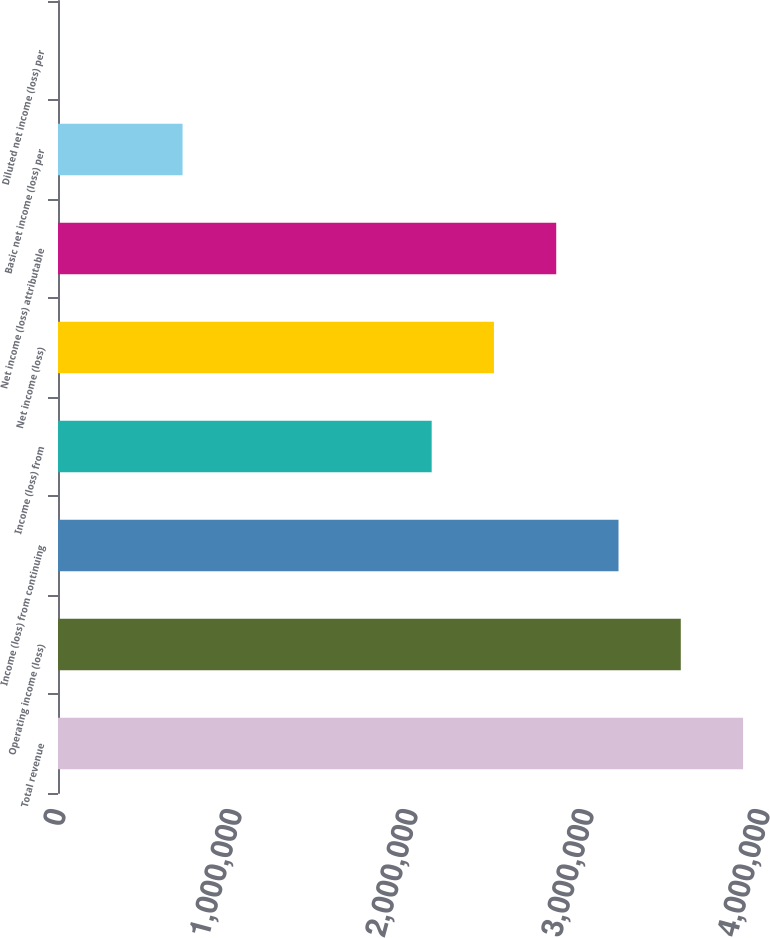<chart> <loc_0><loc_0><loc_500><loc_500><bar_chart><fcel>Total revenue<fcel>Operating income (loss)<fcel>Income (loss) from continuing<fcel>Income (loss) from<fcel>Net income (loss)<fcel>Net income (loss) attributable<fcel>Basic net income (loss) per<fcel>Diluted net income (loss) per<nl><fcel>3.89239e+06<fcel>3.53854e+06<fcel>3.18469e+06<fcel>2.12312e+06<fcel>2.47698e+06<fcel>2.83083e+06<fcel>707708<fcel>0.01<nl></chart> 